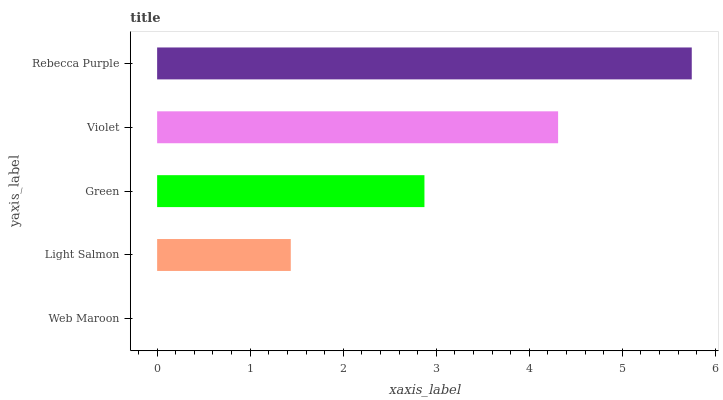Is Web Maroon the minimum?
Answer yes or no. Yes. Is Rebecca Purple the maximum?
Answer yes or no. Yes. Is Light Salmon the minimum?
Answer yes or no. No. Is Light Salmon the maximum?
Answer yes or no. No. Is Light Salmon greater than Web Maroon?
Answer yes or no. Yes. Is Web Maroon less than Light Salmon?
Answer yes or no. Yes. Is Web Maroon greater than Light Salmon?
Answer yes or no. No. Is Light Salmon less than Web Maroon?
Answer yes or no. No. Is Green the high median?
Answer yes or no. Yes. Is Green the low median?
Answer yes or no. Yes. Is Web Maroon the high median?
Answer yes or no. No. Is Web Maroon the low median?
Answer yes or no. No. 